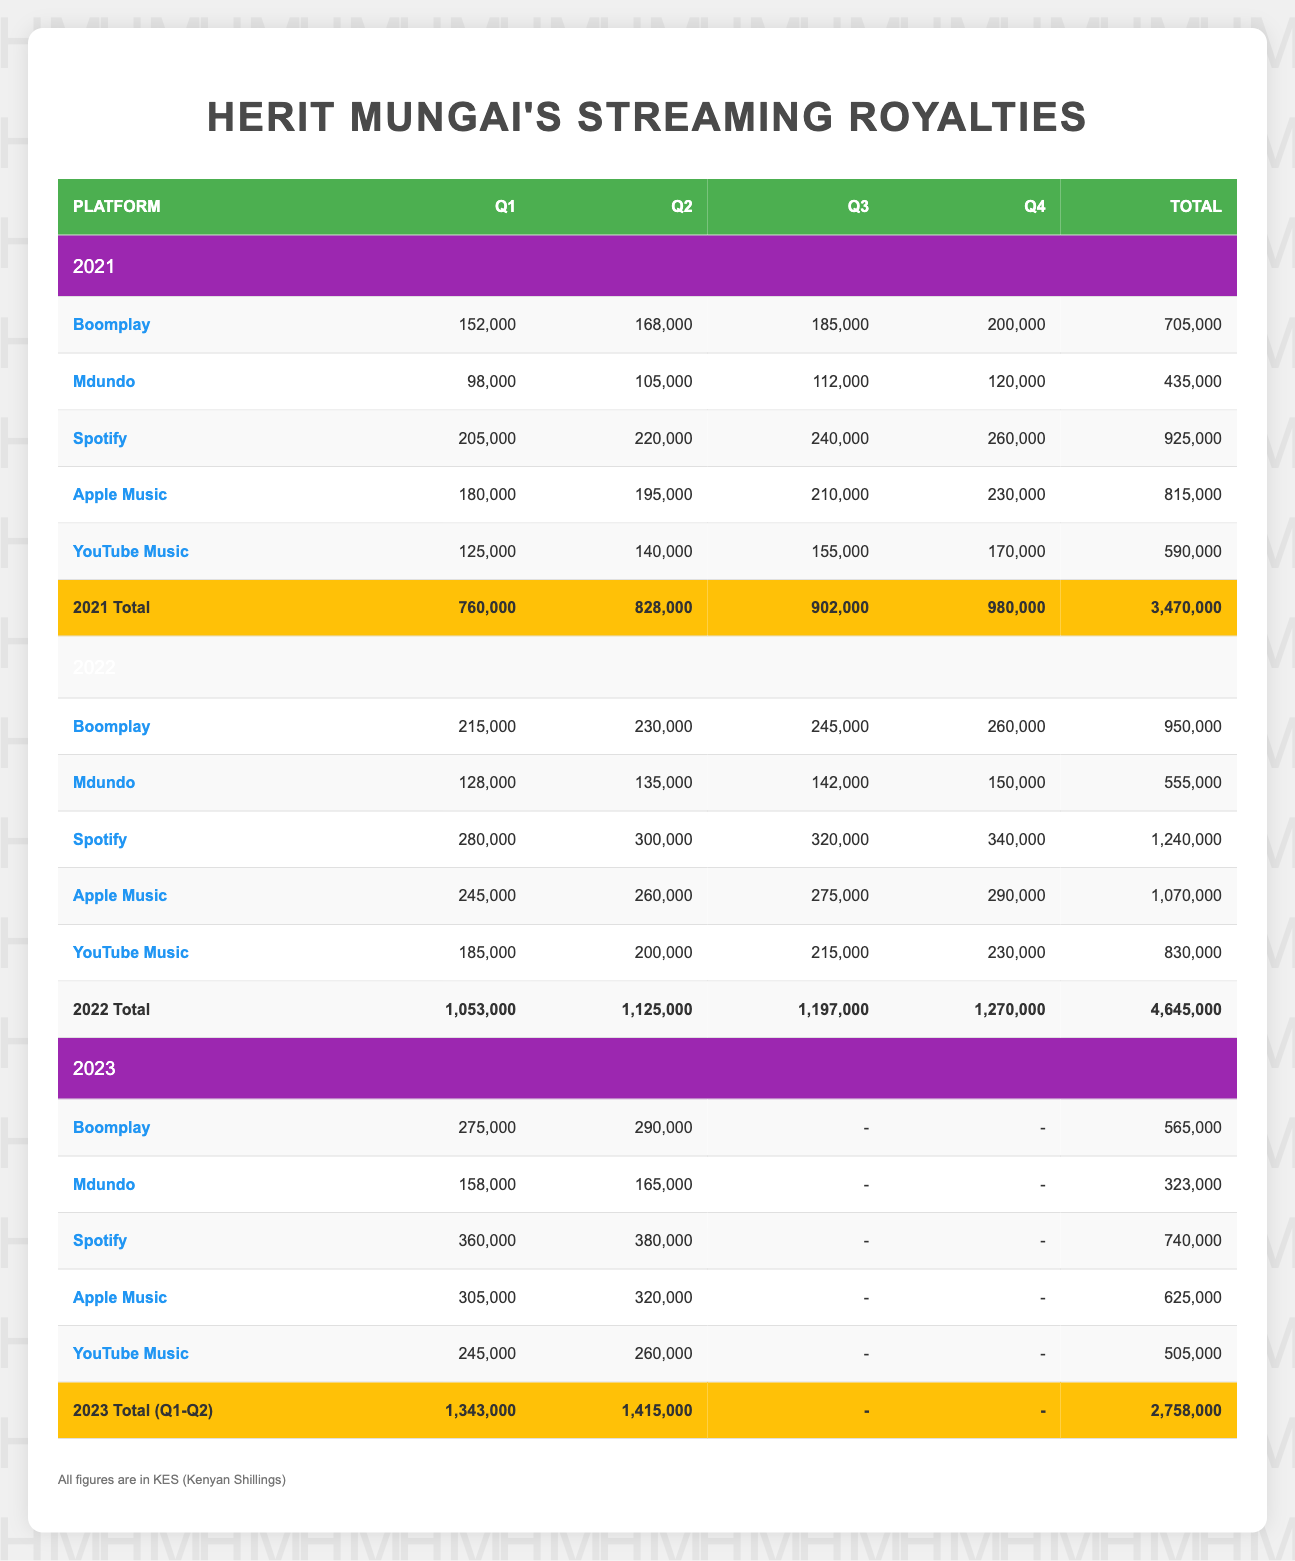What was Herit Mungai's total earnings from Spotify in 2021? To find the total earnings from Spotify in 2021, we need to sum the values for each quarter: Q1 (205000) + Q2 (220000) + Q3 (240000) + Q4 (260000) = 205000 + 220000 + 240000 + 260000 = 925000.
Answer: 925000 How much did Herit Mungai earn from YouTube Music in Q2 of 2022? The earnings from YouTube Music in Q2 of 2022 is directly given in the table as 200000.
Answer: 200000 What was the highest quarterly royalty earning platform for 2023? In 2023, for Q1, Spotify had the highest earning with 360000, and for Q2, Spotify again led with 380000. Thus, the highest platform for both quarters is Spotify.
Answer: Spotify Was there an increase in total earnings from Mdundo from 2021 to 2022? The total earnings from Mdundo in 2021 is 435000, and for 2022 it's 555000. Since 555000 is greater than 435000, there was an increase in earnings.
Answer: Yes What was the total earning from all platforms in Q3 of 2021? To calculate the total earnings in Q3 of 2021, sum the values of all platforms in that quarter: Boomplay (185000) + Mdundo (112000) + Spotify (240000) + Apple Music (210000) + YouTube Music (155000) = 185000 + 112000 + 240000 + 210000 + 155000 = 902000.
Answer: 902000 Which platform had the lowest earnings in Q1 of 2021? In Q1 of 2021, the earnings were as follows: Boomplay (152000), Mdundo (98000), Spotify (205000), Apple Music (180000), and YouTube Music (125000). Mdundo had the lowest earning with 98000.
Answer: Mdundo Calculate the average earnings from Boomplay across all quarters in 2022. First, sum up the earnings for Boomplay in 2022: Q1 (215000) + Q2 (230000) + Q3 (245000) + Q4 (260000) = 215000 + 230000 + 245000 + 260000 = 950000. Then, divide by the number of quarters, which is 4: 950000 / 4 = 237500.
Answer: 237500 Has Herit Mungai earned more than 3 million KES in total from all streaming platforms in 2022? The total earnings for 2022 from the table is 4645000. Since this is greater than 3000000, the answer is yes.
Answer: Yes What is the difference in total earnings from Spotify between 2022 and 2023 so far (Q1 and Q2)? The total earnings from Spotify in 2022 is 1240000 and for 2023 (including Q1 and Q2) is 740000. Now, calculate the difference: 1240000 - 740000 = 500000.
Answer: 500000 